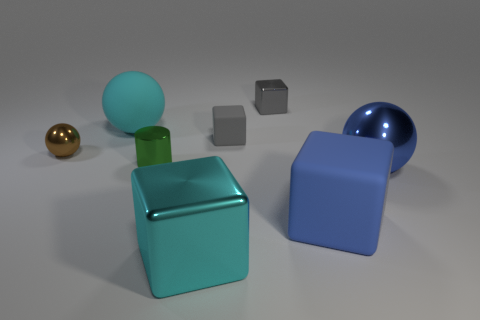If these objects were part of a physics experiment, which two might be used to demonstrate the principles of balance? The blue and green cubes might be used to demonstrate balance principles in a physics experiment due to their symmetrical shapes and stable bases. 